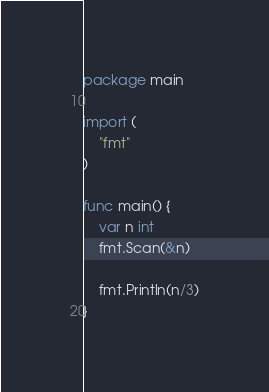<code> <loc_0><loc_0><loc_500><loc_500><_Go_>package main

import (
	"fmt"
)

func main() {
	var n int
	fmt.Scan(&n)

	fmt.Println(n/3)
}</code> 